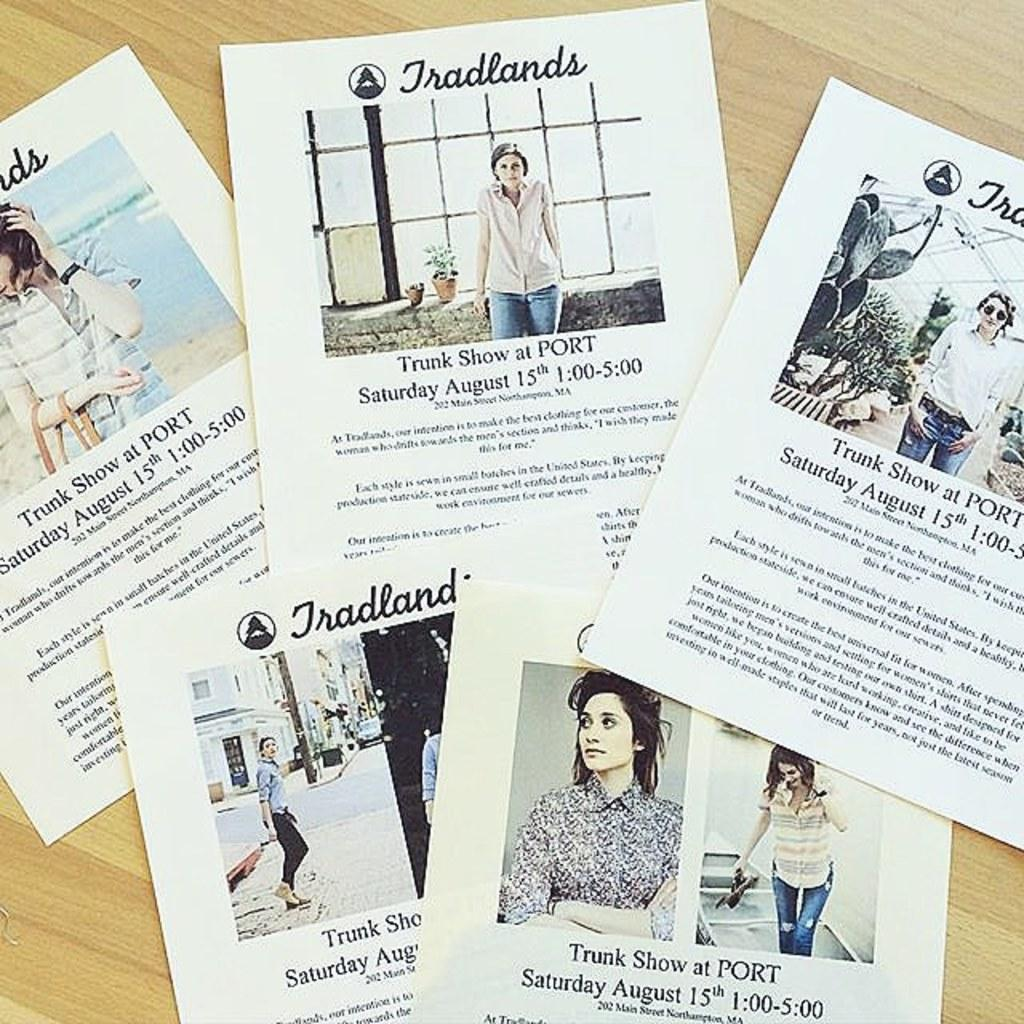What type of printed materials are present in the image? There are pamphlets in the image. On what surface are the pamphlets placed? The pamphlets are on a wooden surface. What is depicted in the images within the pamphlets? The pamphlets contain images of women. What else can be found within the pamphlets besides the images? The pamphlets contain text. Where is the receipt for the beast located in the image? There is no receipt or beast present in the image. What type of creature might be found in the cellar according to the pamphlets? The pamphlets do not mention any creatures or cellars; they contain images of women and text. 